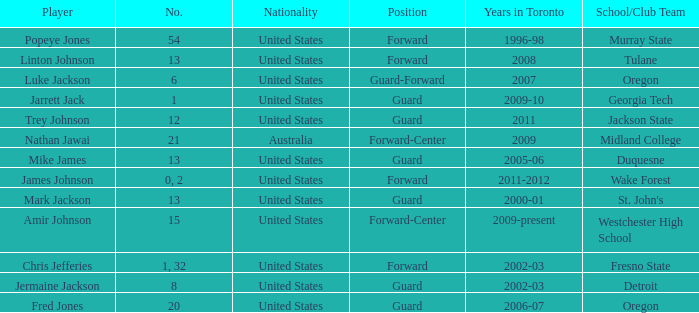Who are all of the players on the Westchester High School club team? Amir Johnson. 